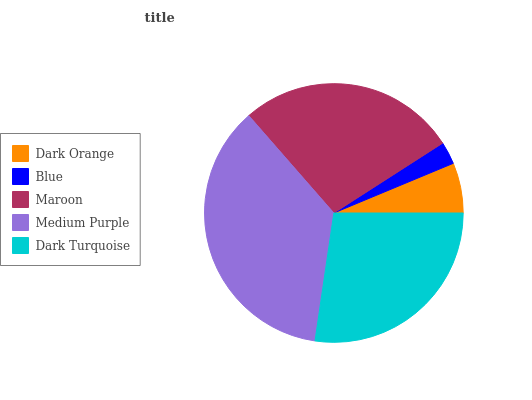Is Blue the minimum?
Answer yes or no. Yes. Is Medium Purple the maximum?
Answer yes or no. Yes. Is Maroon the minimum?
Answer yes or no. No. Is Maroon the maximum?
Answer yes or no. No. Is Maroon greater than Blue?
Answer yes or no. Yes. Is Blue less than Maroon?
Answer yes or no. Yes. Is Blue greater than Maroon?
Answer yes or no. No. Is Maroon less than Blue?
Answer yes or no. No. Is Dark Turquoise the high median?
Answer yes or no. Yes. Is Dark Turquoise the low median?
Answer yes or no. Yes. Is Maroon the high median?
Answer yes or no. No. Is Blue the low median?
Answer yes or no. No. 